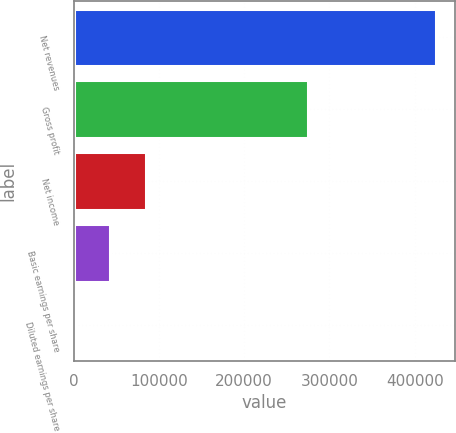Convert chart to OTSL. <chart><loc_0><loc_0><loc_500><loc_500><bar_chart><fcel>Net revenues<fcel>Gross profit<fcel>Net income<fcel>Basic earnings per share<fcel>Diluted earnings per share<nl><fcel>425505<fcel>274860<fcel>85101.7<fcel>42551.3<fcel>0.91<nl></chart> 